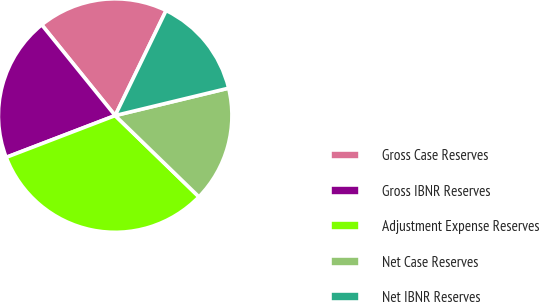Convert chart to OTSL. <chart><loc_0><loc_0><loc_500><loc_500><pie_chart><fcel>Gross Case Reserves<fcel>Gross IBNR Reserves<fcel>Adjustment Expense Reserves<fcel>Net Case Reserves<fcel>Net IBNR Reserves<nl><fcel>18.01%<fcel>20.0%<fcel>31.91%<fcel>16.03%<fcel>14.04%<nl></chart> 